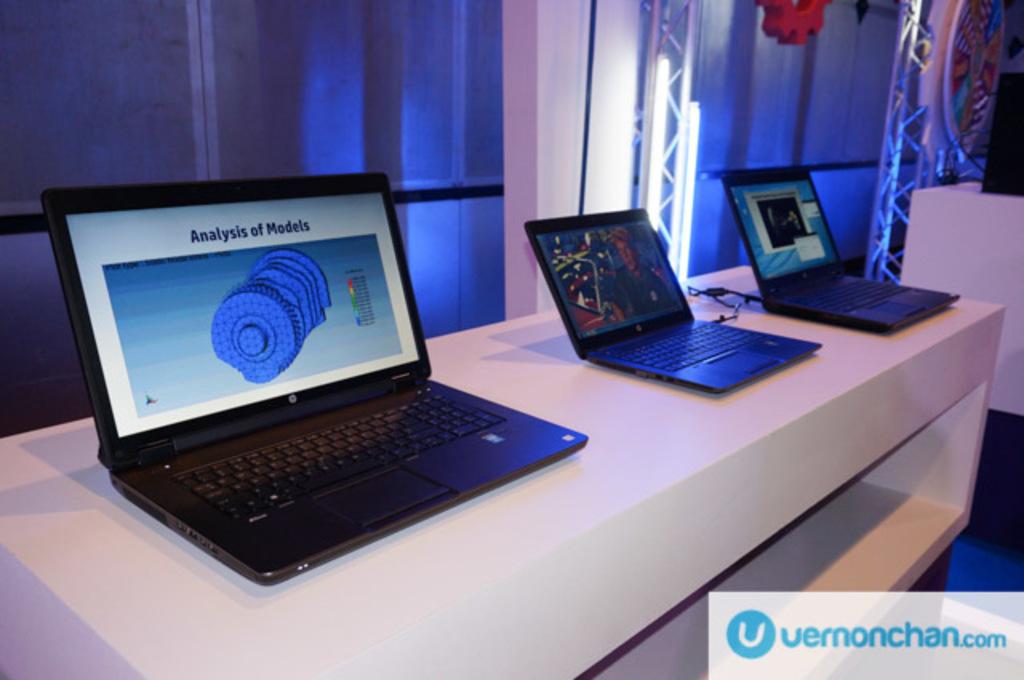What is the analysis of on the computer?
Your response must be concise. Models. What is the website?
Offer a very short reply. Vernonchan.com. 